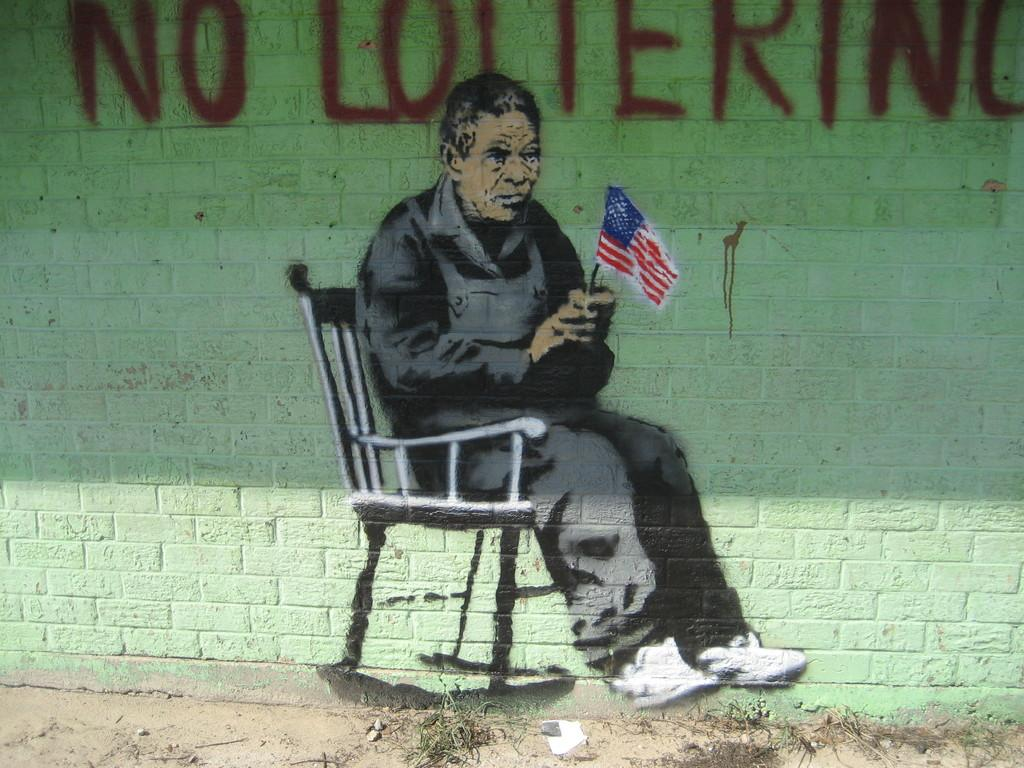What is the main subject of the image? There is a painting in the image. What is happening in the painting? The painting depicts a person sitting on a chair and holding a flag. Where is the painting located? The painting is on a wall. What additional information is provided at the top of the image? There is text written at the top of the image. How many tramps are visible in the painting? There are no tramps depicted in the painting; it features a person sitting on a chair and holding a flag. What type of pail is being used by the person in the painting? There is no pail present in the painting; the person is holding a flag. 